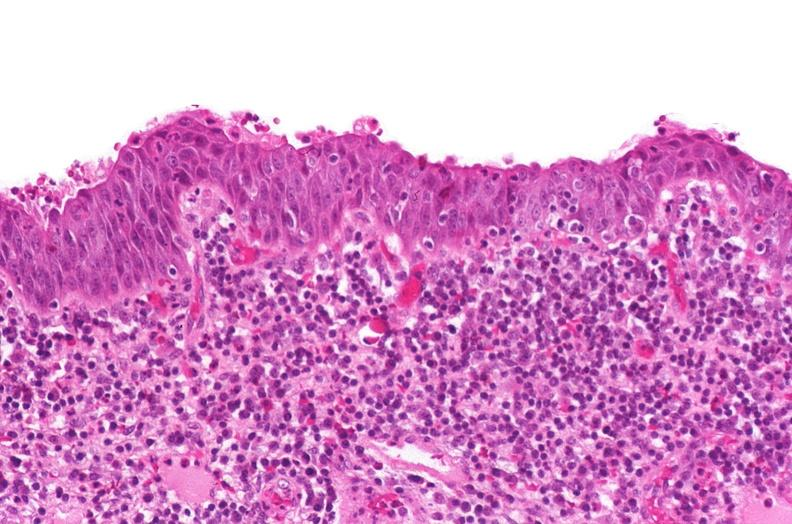what is present?
Answer the question using a single word or phrase. Urinary 